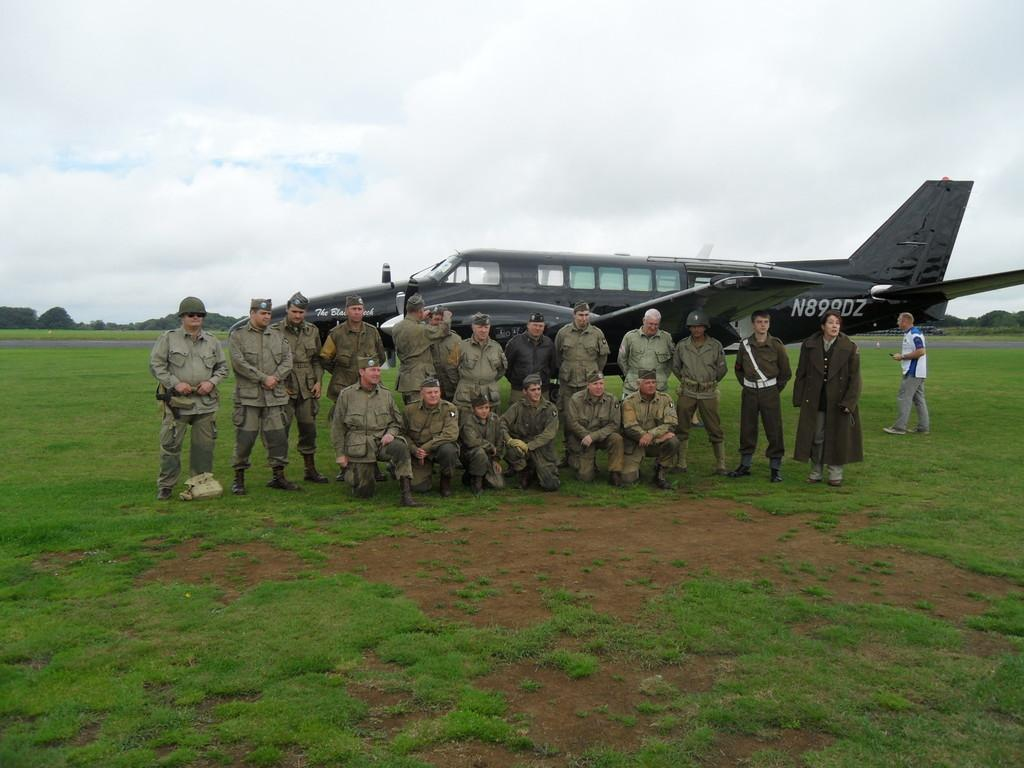<image>
Describe the image concisely. A group of airmen are posing next to a green plane with the tail number N899DZ 